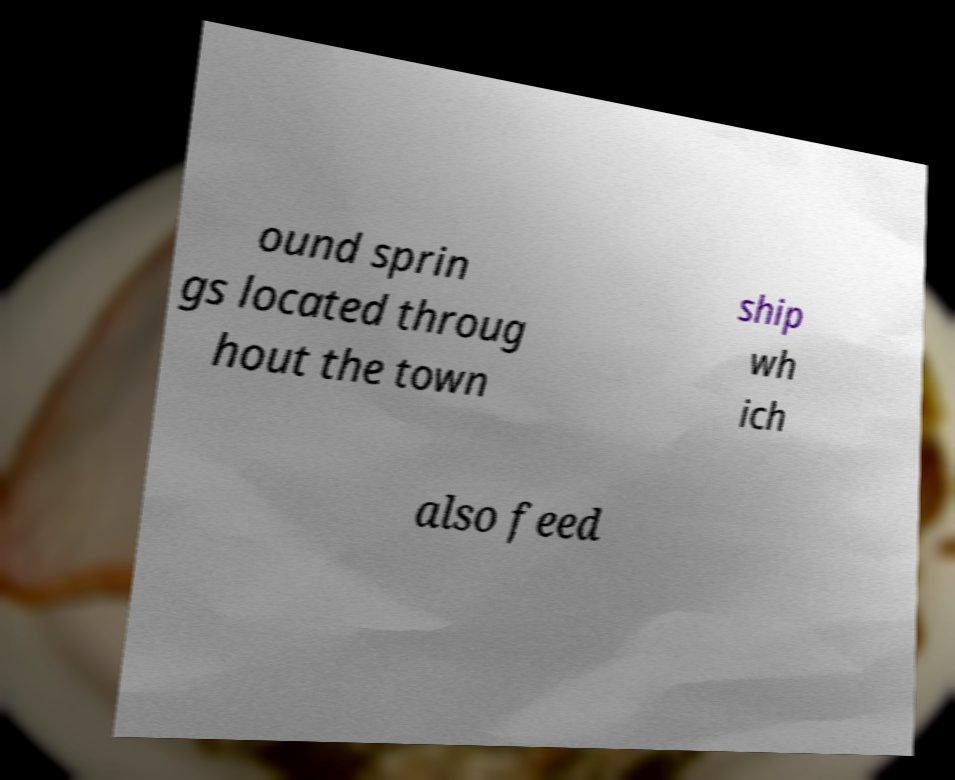Could you assist in decoding the text presented in this image and type it out clearly? ound sprin gs located throug hout the town ship wh ich also feed 